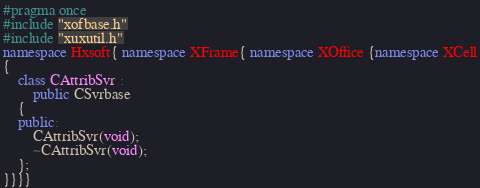Convert code to text. <code><loc_0><loc_0><loc_500><loc_500><_C++_>#pragma once
#include "xofbase.h"
#include "xuxutil.h"
namespace Hxsoft{ namespace XFrame{ namespace XOffice {namespace XCell
{
	class CAttribSvr :
		public CSvrbase
	{
	public:
		CAttribSvr(void);
		~CAttribSvr(void);
	};
}}}}
</code> 